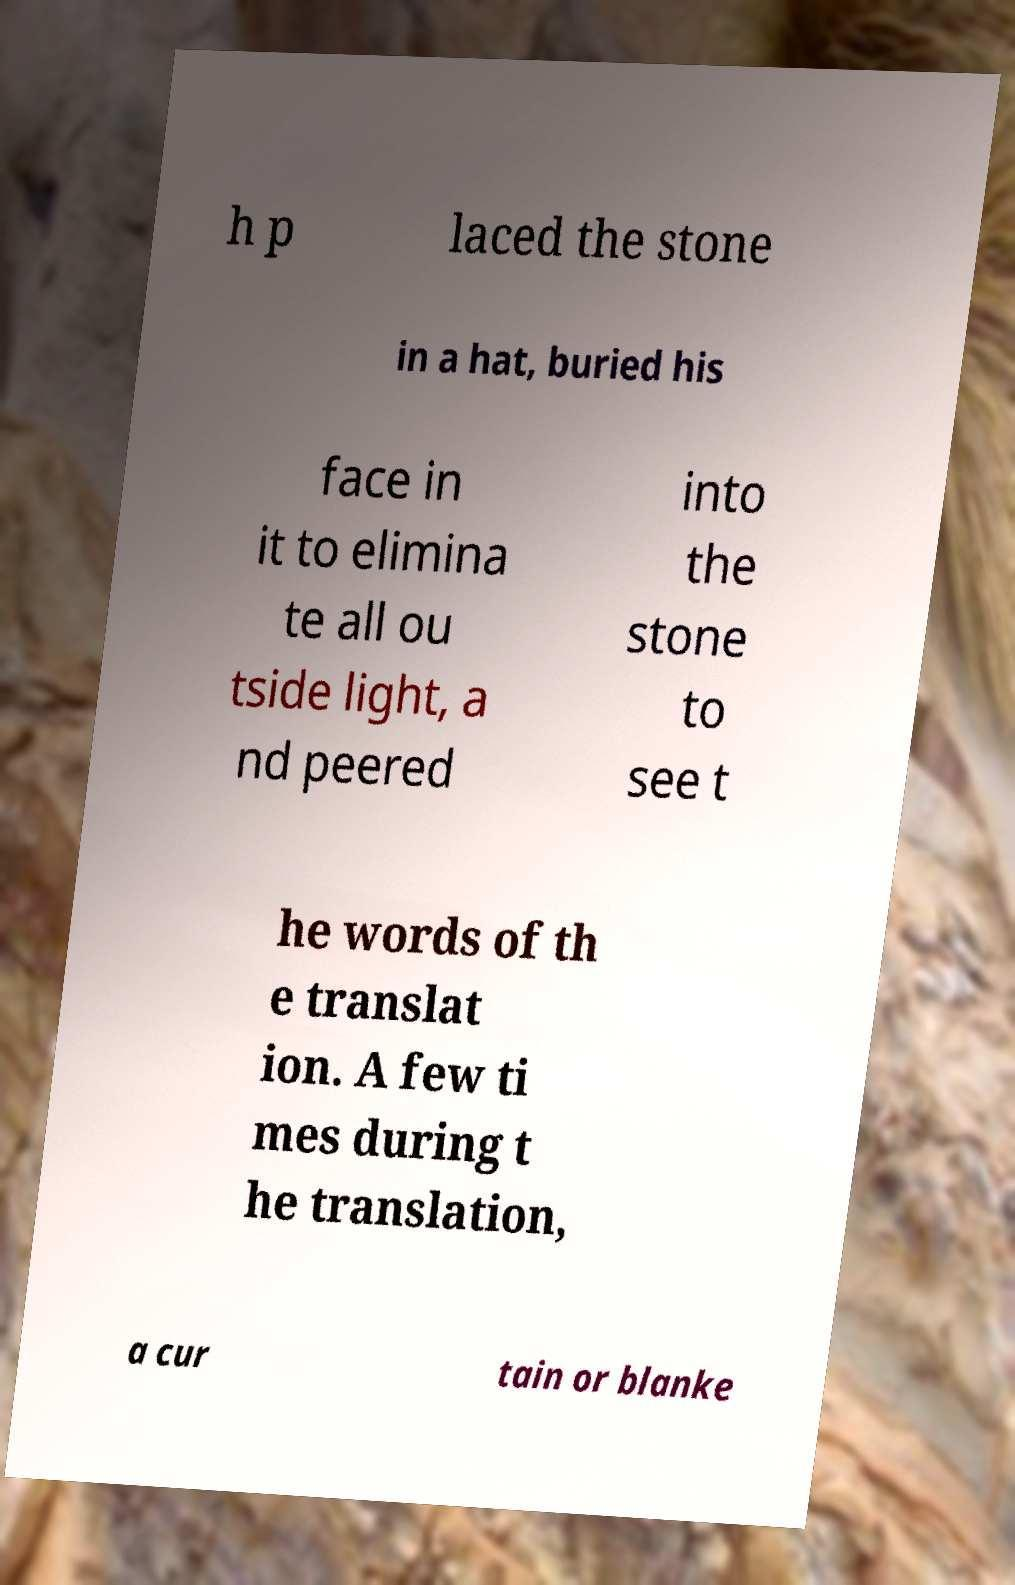Please read and relay the text visible in this image. What does it say? h p laced the stone in a hat, buried his face in it to elimina te all ou tside light, a nd peered into the stone to see t he words of th e translat ion. A few ti mes during t he translation, a cur tain or blanke 